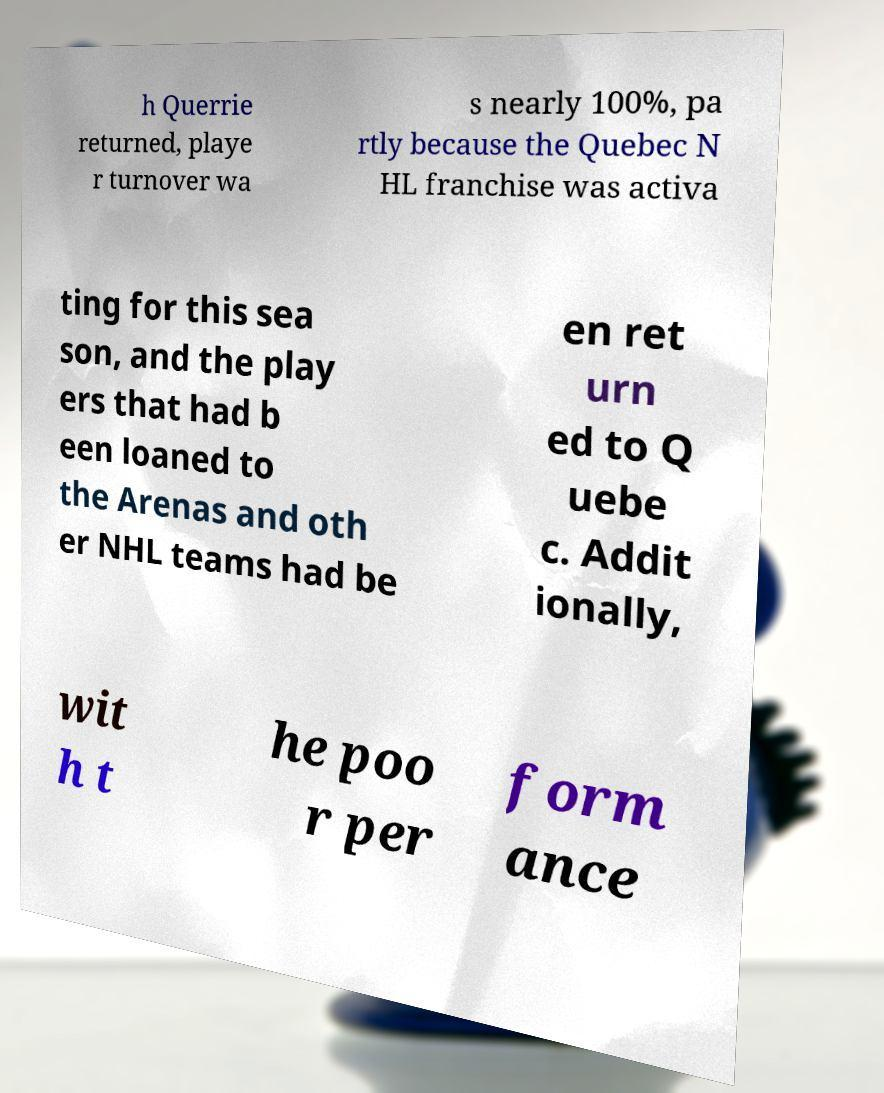Could you assist in decoding the text presented in this image and type it out clearly? h Querrie returned, playe r turnover wa s nearly 100%, pa rtly because the Quebec N HL franchise was activa ting for this sea son, and the play ers that had b een loaned to the Arenas and oth er NHL teams had be en ret urn ed to Q uebe c. Addit ionally, wit h t he poo r per form ance 